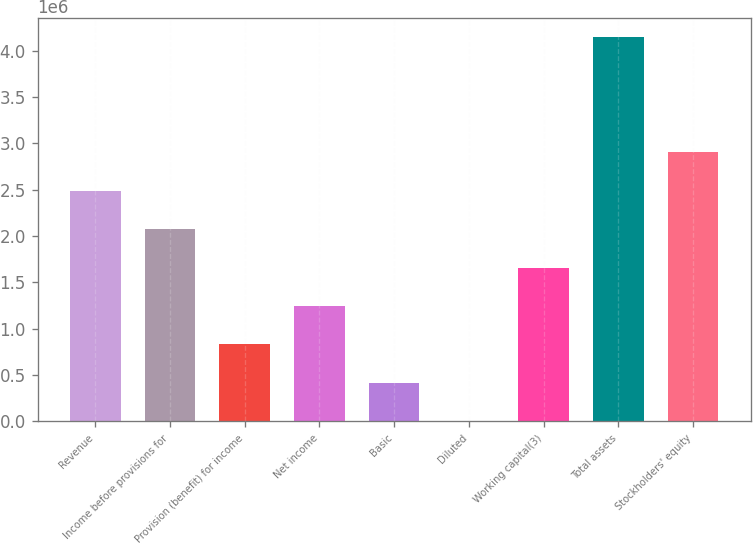<chart> <loc_0><loc_0><loc_500><loc_500><bar_chart><fcel>Revenue<fcel>Income before provisions for<fcel>Provision (benefit) for income<fcel>Net income<fcel>Basic<fcel>Diluted<fcel>Working capital(3)<fcel>Total assets<fcel>Stockholders' equity<nl><fcel>2.48859e+06<fcel>2.07383e+06<fcel>829532<fcel>1.2443e+06<fcel>414767<fcel>1.21<fcel>1.65906e+06<fcel>4.14766e+06<fcel>2.90336e+06<nl></chart> 